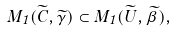Convert formula to latex. <formula><loc_0><loc_0><loc_500><loc_500>M _ { 1 } ( \widetilde { C } , \widetilde { \gamma } ) \subset M _ { 1 } ( \widetilde { U } , \widetilde { \beta } ) ,</formula> 